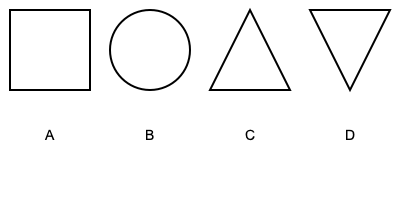Which of the geometric shapes shown above is most commonly found in traditional Ukrainian embroidery patterns, particularly those inspired by folklore? To answer this question, let's analyze each shape and its significance in Ukrainian folklore embroidery:

1. Shape A: Square - While squares are used in Ukrainian embroidery, they are not as prevalent as some other shapes.

2. Shape B: Circle - Circles are important in Ukrainian folklore, often representing the sun or cycles of life. However, they are not the most common shape in embroidery patterns.

3. Shape C: Equilateral Triangle - Triangles are very significant in Ukrainian folklore embroidery. They are often used to represent elements like mountains, fire, or spiritual trinities. Equilateral triangles, in particular, are frequently found in traditional patterns.

4. Shape D: Rhombus (Diamond) - The rhombus is the most commonly used geometric shape in Ukrainian embroidery. It is deeply rooted in Ukrainian folklore and symbolism, often representing fertility, femininity, or protection. Rhombuses are frequently combined to create intricate patterns in traditional embroidery.

Given the prevalence and cultural significance of the rhombus in Ukrainian folklore-inspired embroidery, shape D is the correct answer.
Answer: D (Rhombus) 